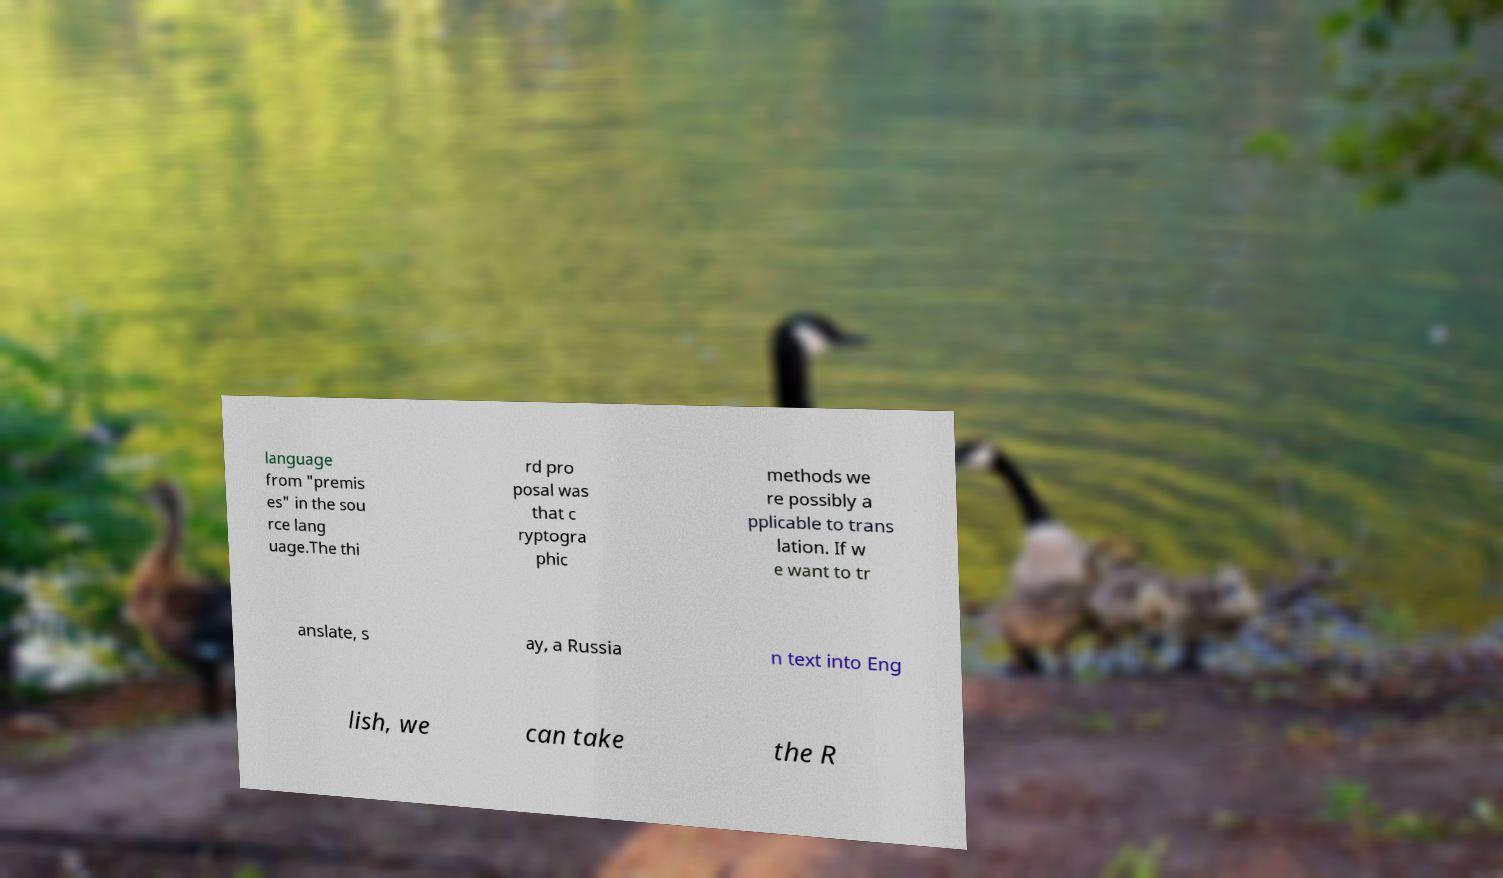Please identify and transcribe the text found in this image. language from "premis es" in the sou rce lang uage.The thi rd pro posal was that c ryptogra phic methods we re possibly a pplicable to trans lation. If w e want to tr anslate, s ay, a Russia n text into Eng lish, we can take the R 